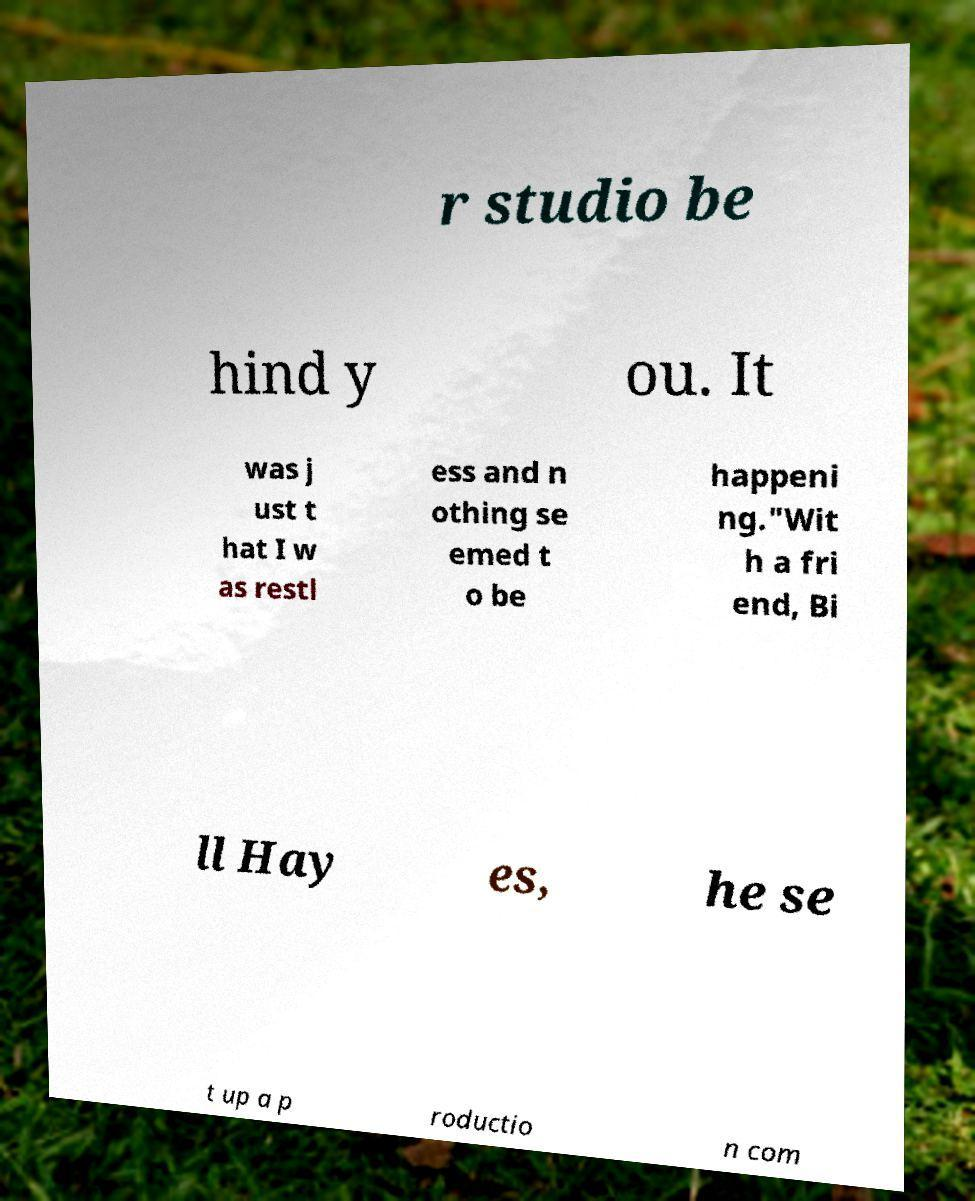I need the written content from this picture converted into text. Can you do that? r studio be hind y ou. It was j ust t hat I w as restl ess and n othing se emed t o be happeni ng."Wit h a fri end, Bi ll Hay es, he se t up a p roductio n com 